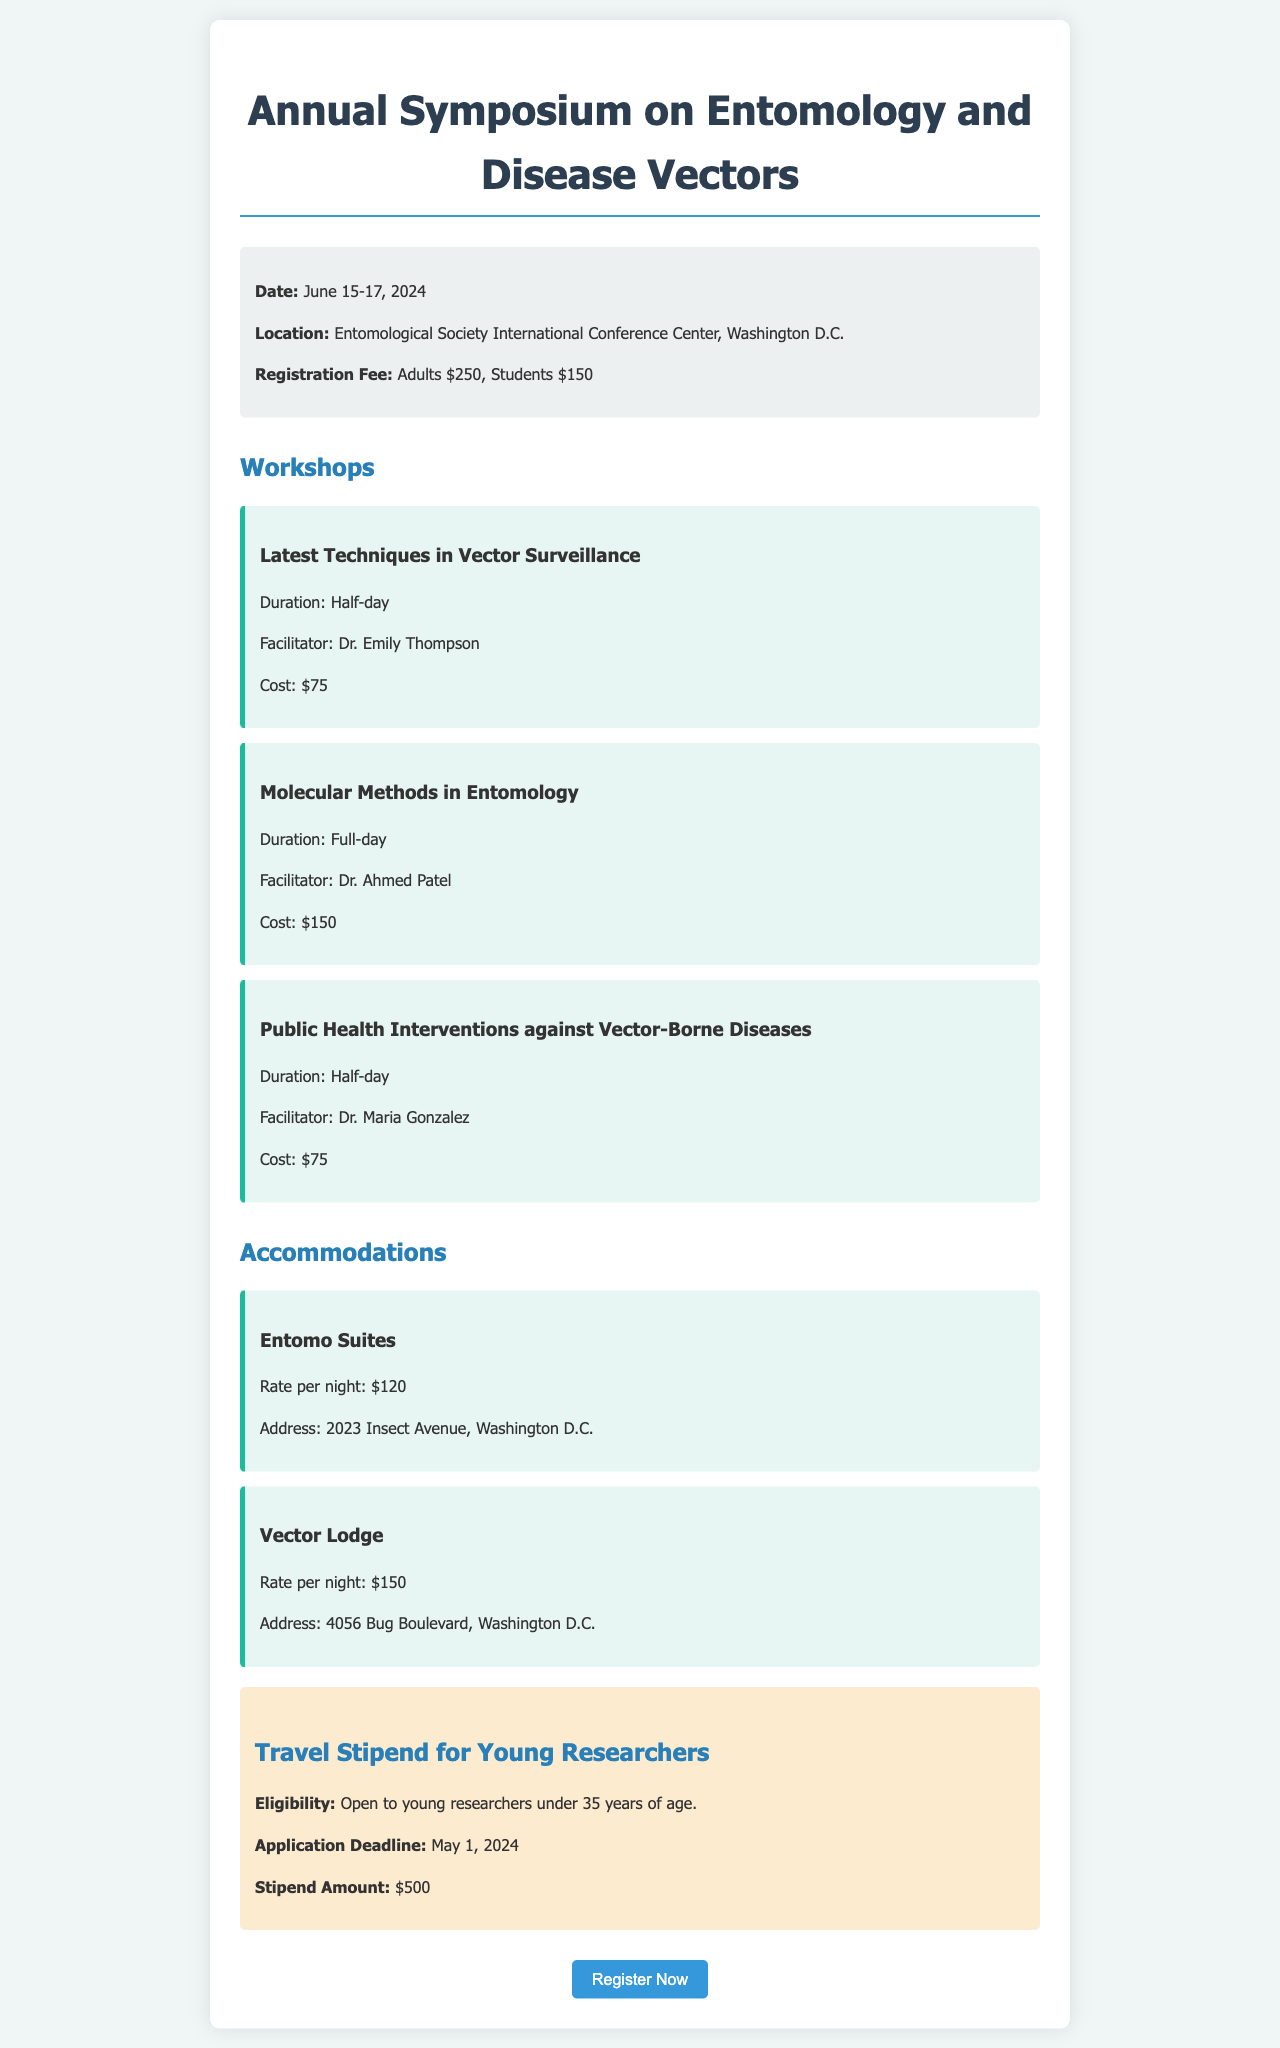what are the dates of the symposium? The dates of the symposium are explicitly stated in the information section of the document.
Answer: June 15-17, 2024 who is the facilitator for the workshop on Molecular Methods in Entomology? Each workshop in the document includes the name of the facilitator, specifically for this workshop.
Answer: Dr. Ahmed Patel what is the registration fee for students? The document clearly mentions the registration fees for both adults and students.
Answer: $150 what is the stipend amount for young researchers? The stipend amount is detailed in the travel stipend section of the document.
Answer: $500 how many workshops are offered? By counting the workshops mentioned in the section, we can find the total number of workshops available.
Answer: 3 what is the rate per night for Vector Lodge? The accommodation section specifies the rates for each hotel, including Vector Lodge.
Answer: $150 what is the application deadline for the travel stipend? The deadline for the stipend application is listed in the stipend section.
Answer: May 1, 2024 which hotel has the lower rate? The rates for both hotels are provided, allowing for comparison to identify the lower rate.
Answer: Entomo Suites what is the duration of the workshop on Public Health Interventions? Each workshop includes a duration in the description, including this specific workshop's duration.
Answer: Half-day 